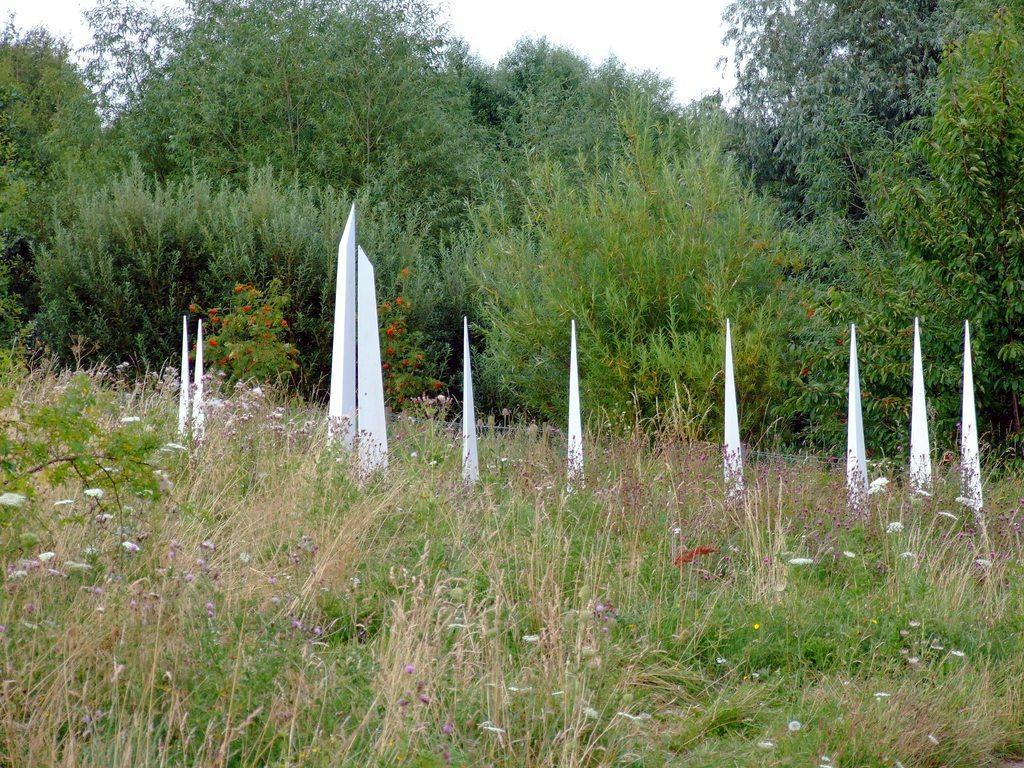What type of vegetation can be seen in the image? There are trees and plants with flowers in the image. What is the ground covered with in the image? There is grass in the image. What objects made of wood are present in the image? There are wooden sticks in the image. What can be seen in the background of the image? The sky is visible in the background of the image. How many babies are crawling on the line in the image? There are no babies or lines present in the image. What type of pencil can be seen in the image? There is no pencil present in the image. 